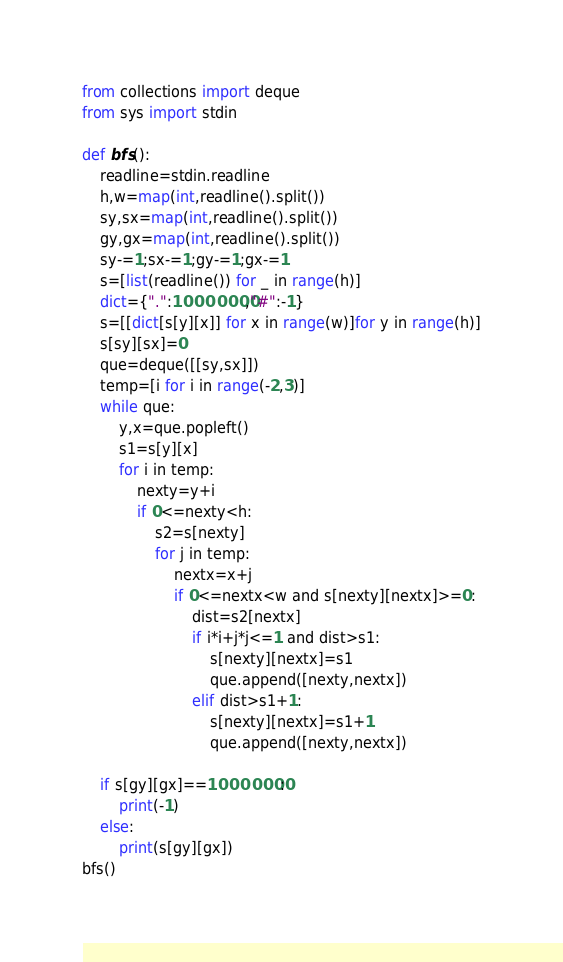<code> <loc_0><loc_0><loc_500><loc_500><_Python_>from collections import deque
from sys import stdin

def bfs():
    readline=stdin.readline
    h,w=map(int,readline().split())
    sy,sx=map(int,readline().split())
    gy,gx=map(int,readline().split())
    sy-=1;sx-=1;gy-=1;gx-=1
    s=[list(readline()) for _ in range(h)]
    dict={".":10000000,"#":-1}
    s=[[dict[s[y][x]] for x in range(w)]for y in range(h)]
    s[sy][sx]=0
    que=deque([[sy,sx]])
    temp=[i for i in range(-2,3)]
    while que:
        y,x=que.popleft()
        s1=s[y][x]
        for i in temp:
            nexty=y+i
            if 0<=nexty<h:
                s2=s[nexty]
                for j in temp:
                    nextx=x+j
                    if 0<=nextx<w and s[nexty][nextx]>=0:
                        dist=s2[nextx]
                        if i*i+j*j<=1 and dist>s1:
                            s[nexty][nextx]=s1
                            que.append([nexty,nextx])
                        elif dist>s1+1:
                            s[nexty][nextx]=s1+1
                            que.append([nexty,nextx])

    if s[gy][gx]==10000000:
        print(-1)
    else:
        print(s[gy][gx])
bfs()
</code> 